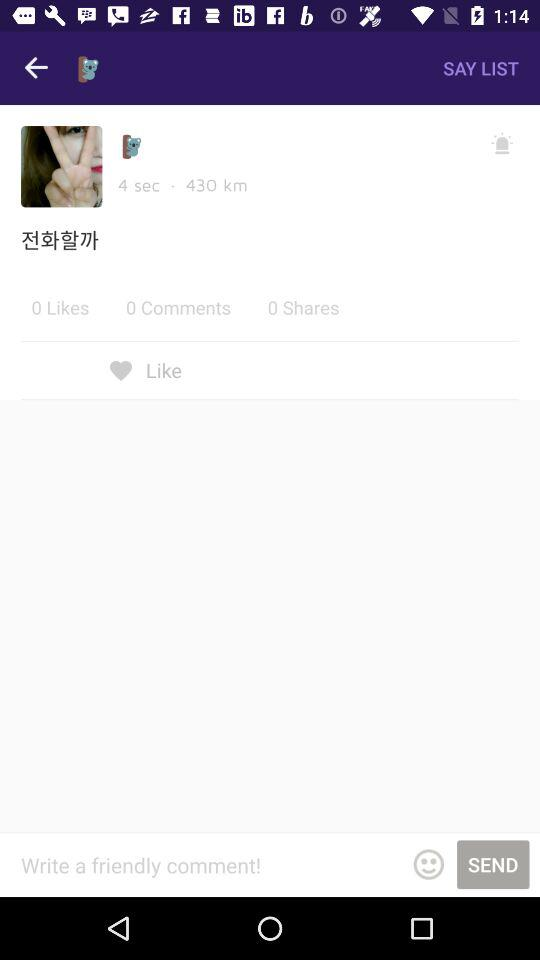What's the distance? The distance is 430 km. 